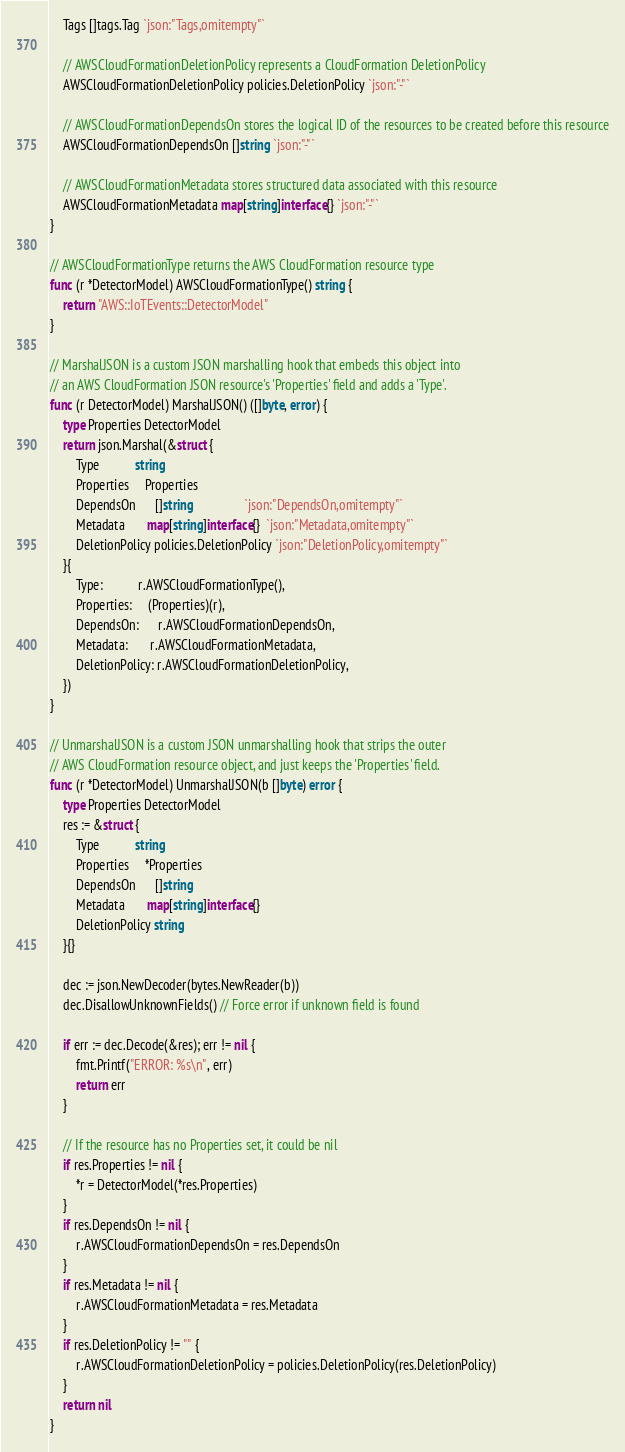Convert code to text. <code><loc_0><loc_0><loc_500><loc_500><_Go_>	Tags []tags.Tag `json:"Tags,omitempty"`

	// AWSCloudFormationDeletionPolicy represents a CloudFormation DeletionPolicy
	AWSCloudFormationDeletionPolicy policies.DeletionPolicy `json:"-"`

	// AWSCloudFormationDependsOn stores the logical ID of the resources to be created before this resource
	AWSCloudFormationDependsOn []string `json:"-"`

	// AWSCloudFormationMetadata stores structured data associated with this resource
	AWSCloudFormationMetadata map[string]interface{} `json:"-"`
}

// AWSCloudFormationType returns the AWS CloudFormation resource type
func (r *DetectorModel) AWSCloudFormationType() string {
	return "AWS::IoTEvents::DetectorModel"
}

// MarshalJSON is a custom JSON marshalling hook that embeds this object into
// an AWS CloudFormation JSON resource's 'Properties' field and adds a 'Type'.
func (r DetectorModel) MarshalJSON() ([]byte, error) {
	type Properties DetectorModel
	return json.Marshal(&struct {
		Type           string
		Properties     Properties
		DependsOn      []string                `json:"DependsOn,omitempty"`
		Metadata       map[string]interface{}  `json:"Metadata,omitempty"`
		DeletionPolicy policies.DeletionPolicy `json:"DeletionPolicy,omitempty"`
	}{
		Type:           r.AWSCloudFormationType(),
		Properties:     (Properties)(r),
		DependsOn:      r.AWSCloudFormationDependsOn,
		Metadata:       r.AWSCloudFormationMetadata,
		DeletionPolicy: r.AWSCloudFormationDeletionPolicy,
	})
}

// UnmarshalJSON is a custom JSON unmarshalling hook that strips the outer
// AWS CloudFormation resource object, and just keeps the 'Properties' field.
func (r *DetectorModel) UnmarshalJSON(b []byte) error {
	type Properties DetectorModel
	res := &struct {
		Type           string
		Properties     *Properties
		DependsOn      []string
		Metadata       map[string]interface{}
		DeletionPolicy string
	}{}

	dec := json.NewDecoder(bytes.NewReader(b))
	dec.DisallowUnknownFields() // Force error if unknown field is found

	if err := dec.Decode(&res); err != nil {
		fmt.Printf("ERROR: %s\n", err)
		return err
	}

	// If the resource has no Properties set, it could be nil
	if res.Properties != nil {
		*r = DetectorModel(*res.Properties)
	}
	if res.DependsOn != nil {
		r.AWSCloudFormationDependsOn = res.DependsOn
	}
	if res.Metadata != nil {
		r.AWSCloudFormationMetadata = res.Metadata
	}
	if res.DeletionPolicy != "" {
		r.AWSCloudFormationDeletionPolicy = policies.DeletionPolicy(res.DeletionPolicy)
	}
	return nil
}
</code> 